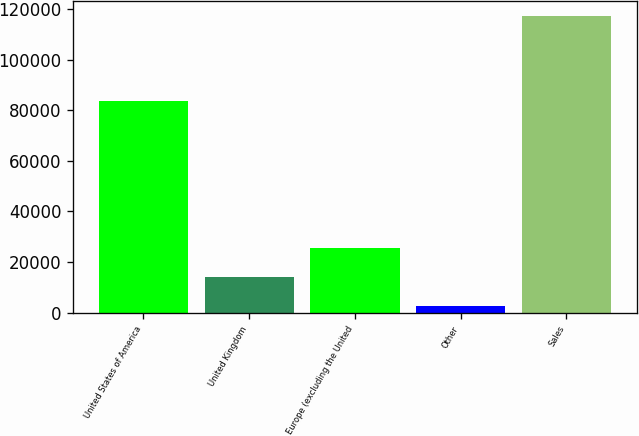Convert chart to OTSL. <chart><loc_0><loc_0><loc_500><loc_500><bar_chart><fcel>United States of America<fcel>United Kingdom<fcel>Europe (excluding the United<fcel>Other<fcel>Sales<nl><fcel>83802<fcel>14142.6<fcel>25610.2<fcel>2675<fcel>117351<nl></chart> 